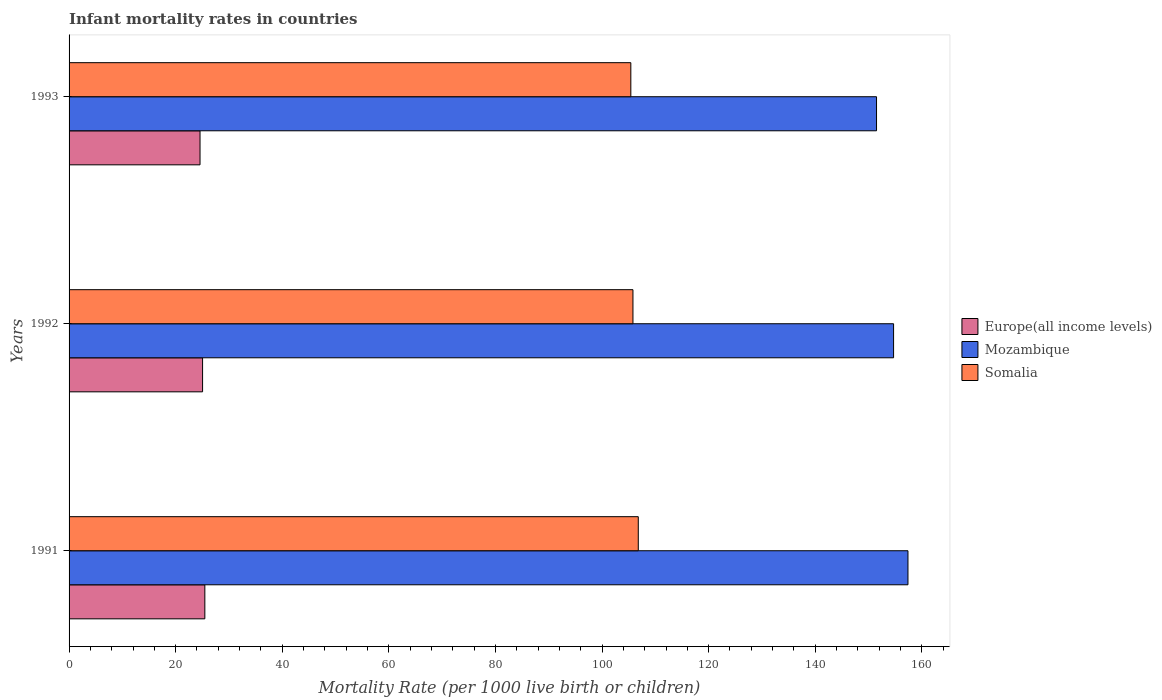How many groups of bars are there?
Your answer should be compact. 3. What is the label of the 1st group of bars from the top?
Your answer should be very brief. 1993. In how many cases, is the number of bars for a given year not equal to the number of legend labels?
Offer a terse response. 0. What is the infant mortality rate in Mozambique in 1991?
Make the answer very short. 157.4. Across all years, what is the maximum infant mortality rate in Somalia?
Give a very brief answer. 106.8. Across all years, what is the minimum infant mortality rate in Somalia?
Provide a short and direct response. 105.4. What is the total infant mortality rate in Somalia in the graph?
Keep it short and to the point. 318. What is the difference between the infant mortality rate in Mozambique in 1991 and that in 1993?
Give a very brief answer. 5.9. What is the difference between the infant mortality rate in Somalia in 1993 and the infant mortality rate in Europe(all income levels) in 1991?
Your response must be concise. 79.92. What is the average infant mortality rate in Somalia per year?
Offer a terse response. 106. In the year 1993, what is the difference between the infant mortality rate in Mozambique and infant mortality rate in Europe(all income levels)?
Ensure brevity in your answer.  126.93. In how many years, is the infant mortality rate in Somalia greater than 56 ?
Your answer should be compact. 3. What is the ratio of the infant mortality rate in Europe(all income levels) in 1991 to that in 1993?
Your answer should be compact. 1.04. What is the difference between the highest and the second highest infant mortality rate in Somalia?
Your answer should be very brief. 1. What is the difference between the highest and the lowest infant mortality rate in Europe(all income levels)?
Offer a terse response. 0.9. In how many years, is the infant mortality rate in Somalia greater than the average infant mortality rate in Somalia taken over all years?
Your response must be concise. 1. What does the 3rd bar from the top in 1992 represents?
Provide a short and direct response. Europe(all income levels). What does the 1st bar from the bottom in 1993 represents?
Make the answer very short. Europe(all income levels). How many bars are there?
Give a very brief answer. 9. Are all the bars in the graph horizontal?
Make the answer very short. Yes. Does the graph contain grids?
Keep it short and to the point. No. Where does the legend appear in the graph?
Your answer should be very brief. Center right. How many legend labels are there?
Make the answer very short. 3. How are the legend labels stacked?
Provide a short and direct response. Vertical. What is the title of the graph?
Give a very brief answer. Infant mortality rates in countries. What is the label or title of the X-axis?
Make the answer very short. Mortality Rate (per 1000 live birth or children). What is the Mortality Rate (per 1000 live birth or children) of Europe(all income levels) in 1991?
Provide a short and direct response. 25.48. What is the Mortality Rate (per 1000 live birth or children) in Mozambique in 1991?
Your response must be concise. 157.4. What is the Mortality Rate (per 1000 live birth or children) in Somalia in 1991?
Your response must be concise. 106.8. What is the Mortality Rate (per 1000 live birth or children) of Europe(all income levels) in 1992?
Your answer should be very brief. 25.05. What is the Mortality Rate (per 1000 live birth or children) in Mozambique in 1992?
Your response must be concise. 154.7. What is the Mortality Rate (per 1000 live birth or children) in Somalia in 1992?
Provide a short and direct response. 105.8. What is the Mortality Rate (per 1000 live birth or children) in Europe(all income levels) in 1993?
Give a very brief answer. 24.57. What is the Mortality Rate (per 1000 live birth or children) of Mozambique in 1993?
Your answer should be very brief. 151.5. What is the Mortality Rate (per 1000 live birth or children) of Somalia in 1993?
Make the answer very short. 105.4. Across all years, what is the maximum Mortality Rate (per 1000 live birth or children) of Europe(all income levels)?
Your response must be concise. 25.48. Across all years, what is the maximum Mortality Rate (per 1000 live birth or children) of Mozambique?
Make the answer very short. 157.4. Across all years, what is the maximum Mortality Rate (per 1000 live birth or children) in Somalia?
Offer a very short reply. 106.8. Across all years, what is the minimum Mortality Rate (per 1000 live birth or children) of Europe(all income levels)?
Provide a short and direct response. 24.57. Across all years, what is the minimum Mortality Rate (per 1000 live birth or children) in Mozambique?
Your answer should be compact. 151.5. Across all years, what is the minimum Mortality Rate (per 1000 live birth or children) of Somalia?
Keep it short and to the point. 105.4. What is the total Mortality Rate (per 1000 live birth or children) of Europe(all income levels) in the graph?
Provide a succinct answer. 75.1. What is the total Mortality Rate (per 1000 live birth or children) in Mozambique in the graph?
Your answer should be very brief. 463.6. What is the total Mortality Rate (per 1000 live birth or children) in Somalia in the graph?
Your answer should be compact. 318. What is the difference between the Mortality Rate (per 1000 live birth or children) of Europe(all income levels) in 1991 and that in 1992?
Offer a terse response. 0.43. What is the difference between the Mortality Rate (per 1000 live birth or children) in Somalia in 1991 and that in 1992?
Offer a very short reply. 1. What is the difference between the Mortality Rate (per 1000 live birth or children) of Europe(all income levels) in 1991 and that in 1993?
Give a very brief answer. 0.9. What is the difference between the Mortality Rate (per 1000 live birth or children) in Europe(all income levels) in 1992 and that in 1993?
Make the answer very short. 0.48. What is the difference between the Mortality Rate (per 1000 live birth or children) in Europe(all income levels) in 1991 and the Mortality Rate (per 1000 live birth or children) in Mozambique in 1992?
Your answer should be compact. -129.22. What is the difference between the Mortality Rate (per 1000 live birth or children) in Europe(all income levels) in 1991 and the Mortality Rate (per 1000 live birth or children) in Somalia in 1992?
Give a very brief answer. -80.32. What is the difference between the Mortality Rate (per 1000 live birth or children) in Mozambique in 1991 and the Mortality Rate (per 1000 live birth or children) in Somalia in 1992?
Your response must be concise. 51.6. What is the difference between the Mortality Rate (per 1000 live birth or children) of Europe(all income levels) in 1991 and the Mortality Rate (per 1000 live birth or children) of Mozambique in 1993?
Keep it short and to the point. -126.02. What is the difference between the Mortality Rate (per 1000 live birth or children) in Europe(all income levels) in 1991 and the Mortality Rate (per 1000 live birth or children) in Somalia in 1993?
Offer a very short reply. -79.92. What is the difference between the Mortality Rate (per 1000 live birth or children) of Mozambique in 1991 and the Mortality Rate (per 1000 live birth or children) of Somalia in 1993?
Your response must be concise. 52. What is the difference between the Mortality Rate (per 1000 live birth or children) of Europe(all income levels) in 1992 and the Mortality Rate (per 1000 live birth or children) of Mozambique in 1993?
Provide a succinct answer. -126.45. What is the difference between the Mortality Rate (per 1000 live birth or children) of Europe(all income levels) in 1992 and the Mortality Rate (per 1000 live birth or children) of Somalia in 1993?
Keep it short and to the point. -80.35. What is the difference between the Mortality Rate (per 1000 live birth or children) of Mozambique in 1992 and the Mortality Rate (per 1000 live birth or children) of Somalia in 1993?
Your response must be concise. 49.3. What is the average Mortality Rate (per 1000 live birth or children) of Europe(all income levels) per year?
Provide a succinct answer. 25.03. What is the average Mortality Rate (per 1000 live birth or children) in Mozambique per year?
Ensure brevity in your answer.  154.53. What is the average Mortality Rate (per 1000 live birth or children) of Somalia per year?
Your answer should be compact. 106. In the year 1991, what is the difference between the Mortality Rate (per 1000 live birth or children) in Europe(all income levels) and Mortality Rate (per 1000 live birth or children) in Mozambique?
Keep it short and to the point. -131.92. In the year 1991, what is the difference between the Mortality Rate (per 1000 live birth or children) in Europe(all income levels) and Mortality Rate (per 1000 live birth or children) in Somalia?
Give a very brief answer. -81.32. In the year 1991, what is the difference between the Mortality Rate (per 1000 live birth or children) of Mozambique and Mortality Rate (per 1000 live birth or children) of Somalia?
Your answer should be very brief. 50.6. In the year 1992, what is the difference between the Mortality Rate (per 1000 live birth or children) of Europe(all income levels) and Mortality Rate (per 1000 live birth or children) of Mozambique?
Your answer should be very brief. -129.65. In the year 1992, what is the difference between the Mortality Rate (per 1000 live birth or children) in Europe(all income levels) and Mortality Rate (per 1000 live birth or children) in Somalia?
Provide a succinct answer. -80.75. In the year 1992, what is the difference between the Mortality Rate (per 1000 live birth or children) of Mozambique and Mortality Rate (per 1000 live birth or children) of Somalia?
Your answer should be compact. 48.9. In the year 1993, what is the difference between the Mortality Rate (per 1000 live birth or children) in Europe(all income levels) and Mortality Rate (per 1000 live birth or children) in Mozambique?
Your answer should be compact. -126.93. In the year 1993, what is the difference between the Mortality Rate (per 1000 live birth or children) of Europe(all income levels) and Mortality Rate (per 1000 live birth or children) of Somalia?
Give a very brief answer. -80.83. In the year 1993, what is the difference between the Mortality Rate (per 1000 live birth or children) in Mozambique and Mortality Rate (per 1000 live birth or children) in Somalia?
Make the answer very short. 46.1. What is the ratio of the Mortality Rate (per 1000 live birth or children) of Mozambique in 1991 to that in 1992?
Offer a terse response. 1.02. What is the ratio of the Mortality Rate (per 1000 live birth or children) in Somalia in 1991 to that in 1992?
Offer a terse response. 1.01. What is the ratio of the Mortality Rate (per 1000 live birth or children) of Europe(all income levels) in 1991 to that in 1993?
Offer a terse response. 1.04. What is the ratio of the Mortality Rate (per 1000 live birth or children) of Mozambique in 1991 to that in 1993?
Keep it short and to the point. 1.04. What is the ratio of the Mortality Rate (per 1000 live birth or children) of Somalia in 1991 to that in 1993?
Your answer should be very brief. 1.01. What is the ratio of the Mortality Rate (per 1000 live birth or children) in Europe(all income levels) in 1992 to that in 1993?
Your answer should be very brief. 1.02. What is the ratio of the Mortality Rate (per 1000 live birth or children) of Mozambique in 1992 to that in 1993?
Provide a short and direct response. 1.02. What is the difference between the highest and the second highest Mortality Rate (per 1000 live birth or children) of Europe(all income levels)?
Provide a succinct answer. 0.43. What is the difference between the highest and the second highest Mortality Rate (per 1000 live birth or children) in Somalia?
Your answer should be compact. 1. What is the difference between the highest and the lowest Mortality Rate (per 1000 live birth or children) in Europe(all income levels)?
Make the answer very short. 0.9. 